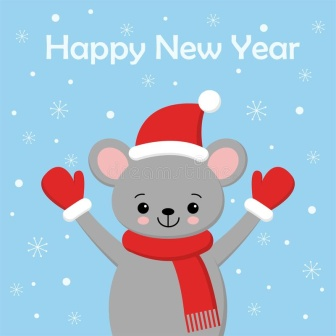If you could step into this scene, what would you feel or experience? Stepping into the scene, one would feel an overwhelming sense of joy and excitement. The festive decorations and the mouse’s exuberant expression would make me feel welcomed and cheerful. The cool winter air, hinted at by the blue background and snowflakes, would add a refreshing touch to the festive atmosphere. The 'Happy New Year' greeting would resonate with a sense of new beginnings and endless possibilities. It would be like being part of a magical winter wonderland where the spirit of the holiday season is alive and infectious. 